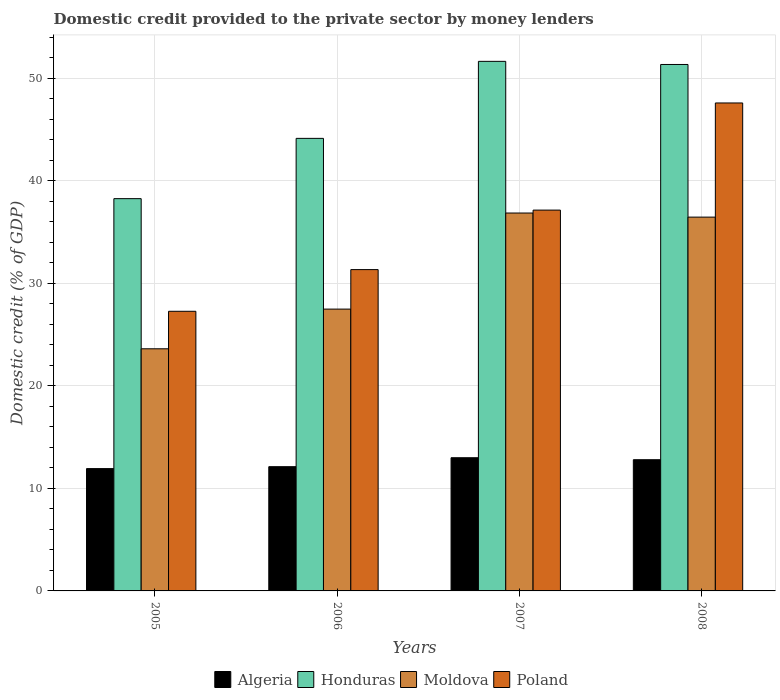How many bars are there on the 2nd tick from the left?
Provide a short and direct response. 4. How many bars are there on the 4th tick from the right?
Give a very brief answer. 4. What is the label of the 1st group of bars from the left?
Give a very brief answer. 2005. What is the domestic credit provided to the private sector by money lenders in Algeria in 2008?
Your answer should be compact. 12.8. Across all years, what is the maximum domestic credit provided to the private sector by money lenders in Poland?
Provide a short and direct response. 47.59. Across all years, what is the minimum domestic credit provided to the private sector by money lenders in Poland?
Provide a short and direct response. 27.27. In which year was the domestic credit provided to the private sector by money lenders in Moldova maximum?
Your response must be concise. 2007. In which year was the domestic credit provided to the private sector by money lenders in Algeria minimum?
Give a very brief answer. 2005. What is the total domestic credit provided to the private sector by money lenders in Honduras in the graph?
Provide a short and direct response. 185.38. What is the difference between the domestic credit provided to the private sector by money lenders in Algeria in 2005 and that in 2006?
Offer a very short reply. -0.19. What is the difference between the domestic credit provided to the private sector by money lenders in Algeria in 2007 and the domestic credit provided to the private sector by money lenders in Poland in 2005?
Provide a succinct answer. -14.28. What is the average domestic credit provided to the private sector by money lenders in Poland per year?
Your answer should be very brief. 35.83. In the year 2007, what is the difference between the domestic credit provided to the private sector by money lenders in Poland and domestic credit provided to the private sector by money lenders in Moldova?
Make the answer very short. 0.28. In how many years, is the domestic credit provided to the private sector by money lenders in Poland greater than 52 %?
Offer a very short reply. 0. What is the ratio of the domestic credit provided to the private sector by money lenders in Moldova in 2005 to that in 2006?
Keep it short and to the point. 0.86. Is the domestic credit provided to the private sector by money lenders in Honduras in 2005 less than that in 2006?
Make the answer very short. Yes. What is the difference between the highest and the second highest domestic credit provided to the private sector by money lenders in Poland?
Give a very brief answer. 10.45. What is the difference between the highest and the lowest domestic credit provided to the private sector by money lenders in Honduras?
Your response must be concise. 13.39. Is it the case that in every year, the sum of the domestic credit provided to the private sector by money lenders in Poland and domestic credit provided to the private sector by money lenders in Moldova is greater than the sum of domestic credit provided to the private sector by money lenders in Honduras and domestic credit provided to the private sector by money lenders in Algeria?
Your answer should be very brief. No. What does the 2nd bar from the left in 2008 represents?
Your answer should be compact. Honduras. What does the 4th bar from the right in 2008 represents?
Keep it short and to the point. Algeria. Is it the case that in every year, the sum of the domestic credit provided to the private sector by money lenders in Algeria and domestic credit provided to the private sector by money lenders in Moldova is greater than the domestic credit provided to the private sector by money lenders in Poland?
Offer a very short reply. Yes. How many bars are there?
Keep it short and to the point. 16. Are all the bars in the graph horizontal?
Provide a short and direct response. No. How many years are there in the graph?
Offer a terse response. 4. Does the graph contain grids?
Offer a very short reply. Yes. Where does the legend appear in the graph?
Your response must be concise. Bottom center. How are the legend labels stacked?
Your response must be concise. Horizontal. What is the title of the graph?
Ensure brevity in your answer.  Domestic credit provided to the private sector by money lenders. Does "Bosnia and Herzegovina" appear as one of the legend labels in the graph?
Provide a succinct answer. No. What is the label or title of the Y-axis?
Provide a short and direct response. Domestic credit (% of GDP). What is the Domestic credit (% of GDP) of Algeria in 2005?
Offer a very short reply. 11.93. What is the Domestic credit (% of GDP) in Honduras in 2005?
Give a very brief answer. 38.26. What is the Domestic credit (% of GDP) in Moldova in 2005?
Your answer should be compact. 23.61. What is the Domestic credit (% of GDP) in Poland in 2005?
Provide a succinct answer. 27.27. What is the Domestic credit (% of GDP) in Algeria in 2006?
Keep it short and to the point. 12.12. What is the Domestic credit (% of GDP) of Honduras in 2006?
Your answer should be very brief. 44.14. What is the Domestic credit (% of GDP) of Moldova in 2006?
Your response must be concise. 27.48. What is the Domestic credit (% of GDP) in Poland in 2006?
Offer a terse response. 31.34. What is the Domestic credit (% of GDP) in Algeria in 2007?
Provide a short and direct response. 12.99. What is the Domestic credit (% of GDP) in Honduras in 2007?
Offer a very short reply. 51.65. What is the Domestic credit (% of GDP) in Moldova in 2007?
Keep it short and to the point. 36.86. What is the Domestic credit (% of GDP) in Poland in 2007?
Offer a very short reply. 37.14. What is the Domestic credit (% of GDP) in Algeria in 2008?
Your response must be concise. 12.8. What is the Domestic credit (% of GDP) in Honduras in 2008?
Offer a terse response. 51.34. What is the Domestic credit (% of GDP) in Moldova in 2008?
Your response must be concise. 36.46. What is the Domestic credit (% of GDP) in Poland in 2008?
Your answer should be compact. 47.59. Across all years, what is the maximum Domestic credit (% of GDP) in Algeria?
Ensure brevity in your answer.  12.99. Across all years, what is the maximum Domestic credit (% of GDP) of Honduras?
Make the answer very short. 51.65. Across all years, what is the maximum Domestic credit (% of GDP) in Moldova?
Provide a succinct answer. 36.86. Across all years, what is the maximum Domestic credit (% of GDP) of Poland?
Give a very brief answer. 47.59. Across all years, what is the minimum Domestic credit (% of GDP) in Algeria?
Provide a succinct answer. 11.93. Across all years, what is the minimum Domestic credit (% of GDP) of Honduras?
Keep it short and to the point. 38.26. Across all years, what is the minimum Domestic credit (% of GDP) in Moldova?
Make the answer very short. 23.61. Across all years, what is the minimum Domestic credit (% of GDP) of Poland?
Your answer should be compact. 27.27. What is the total Domestic credit (% of GDP) of Algeria in the graph?
Provide a succinct answer. 49.83. What is the total Domestic credit (% of GDP) of Honduras in the graph?
Offer a terse response. 185.38. What is the total Domestic credit (% of GDP) in Moldova in the graph?
Your answer should be very brief. 124.41. What is the total Domestic credit (% of GDP) in Poland in the graph?
Offer a very short reply. 143.34. What is the difference between the Domestic credit (% of GDP) in Algeria in 2005 and that in 2006?
Make the answer very short. -0.19. What is the difference between the Domestic credit (% of GDP) of Honduras in 2005 and that in 2006?
Offer a terse response. -5.88. What is the difference between the Domestic credit (% of GDP) in Moldova in 2005 and that in 2006?
Offer a very short reply. -3.87. What is the difference between the Domestic credit (% of GDP) of Poland in 2005 and that in 2006?
Your answer should be very brief. -4.07. What is the difference between the Domestic credit (% of GDP) of Algeria in 2005 and that in 2007?
Give a very brief answer. -1.06. What is the difference between the Domestic credit (% of GDP) of Honduras in 2005 and that in 2007?
Provide a succinct answer. -13.39. What is the difference between the Domestic credit (% of GDP) in Moldova in 2005 and that in 2007?
Your answer should be compact. -13.24. What is the difference between the Domestic credit (% of GDP) in Poland in 2005 and that in 2007?
Offer a very short reply. -9.87. What is the difference between the Domestic credit (% of GDP) of Algeria in 2005 and that in 2008?
Make the answer very short. -0.87. What is the difference between the Domestic credit (% of GDP) of Honduras in 2005 and that in 2008?
Offer a very short reply. -13.09. What is the difference between the Domestic credit (% of GDP) in Moldova in 2005 and that in 2008?
Ensure brevity in your answer.  -12.84. What is the difference between the Domestic credit (% of GDP) of Poland in 2005 and that in 2008?
Your response must be concise. -20.32. What is the difference between the Domestic credit (% of GDP) of Algeria in 2006 and that in 2007?
Ensure brevity in your answer.  -0.87. What is the difference between the Domestic credit (% of GDP) in Honduras in 2006 and that in 2007?
Keep it short and to the point. -7.51. What is the difference between the Domestic credit (% of GDP) in Moldova in 2006 and that in 2007?
Offer a terse response. -9.37. What is the difference between the Domestic credit (% of GDP) of Poland in 2006 and that in 2007?
Your answer should be compact. -5.8. What is the difference between the Domestic credit (% of GDP) in Algeria in 2006 and that in 2008?
Your answer should be compact. -0.68. What is the difference between the Domestic credit (% of GDP) of Honduras in 2006 and that in 2008?
Make the answer very short. -7.21. What is the difference between the Domestic credit (% of GDP) in Moldova in 2006 and that in 2008?
Offer a terse response. -8.97. What is the difference between the Domestic credit (% of GDP) of Poland in 2006 and that in 2008?
Ensure brevity in your answer.  -16.25. What is the difference between the Domestic credit (% of GDP) of Algeria in 2007 and that in 2008?
Ensure brevity in your answer.  0.19. What is the difference between the Domestic credit (% of GDP) in Honduras in 2007 and that in 2008?
Give a very brief answer. 0.3. What is the difference between the Domestic credit (% of GDP) in Moldova in 2007 and that in 2008?
Keep it short and to the point. 0.4. What is the difference between the Domestic credit (% of GDP) of Poland in 2007 and that in 2008?
Your response must be concise. -10.45. What is the difference between the Domestic credit (% of GDP) of Algeria in 2005 and the Domestic credit (% of GDP) of Honduras in 2006?
Your answer should be very brief. -32.21. What is the difference between the Domestic credit (% of GDP) of Algeria in 2005 and the Domestic credit (% of GDP) of Moldova in 2006?
Make the answer very short. -15.56. What is the difference between the Domestic credit (% of GDP) in Algeria in 2005 and the Domestic credit (% of GDP) in Poland in 2006?
Your answer should be very brief. -19.41. What is the difference between the Domestic credit (% of GDP) in Honduras in 2005 and the Domestic credit (% of GDP) in Moldova in 2006?
Keep it short and to the point. 10.77. What is the difference between the Domestic credit (% of GDP) of Honduras in 2005 and the Domestic credit (% of GDP) of Poland in 2006?
Provide a short and direct response. 6.92. What is the difference between the Domestic credit (% of GDP) of Moldova in 2005 and the Domestic credit (% of GDP) of Poland in 2006?
Give a very brief answer. -7.72. What is the difference between the Domestic credit (% of GDP) in Algeria in 2005 and the Domestic credit (% of GDP) in Honduras in 2007?
Provide a succinct answer. -39.72. What is the difference between the Domestic credit (% of GDP) in Algeria in 2005 and the Domestic credit (% of GDP) in Moldova in 2007?
Your answer should be very brief. -24.93. What is the difference between the Domestic credit (% of GDP) in Algeria in 2005 and the Domestic credit (% of GDP) in Poland in 2007?
Your answer should be compact. -25.21. What is the difference between the Domestic credit (% of GDP) in Honduras in 2005 and the Domestic credit (% of GDP) in Moldova in 2007?
Give a very brief answer. 1.4. What is the difference between the Domestic credit (% of GDP) in Honduras in 2005 and the Domestic credit (% of GDP) in Poland in 2007?
Your response must be concise. 1.12. What is the difference between the Domestic credit (% of GDP) of Moldova in 2005 and the Domestic credit (% of GDP) of Poland in 2007?
Your answer should be very brief. -13.53. What is the difference between the Domestic credit (% of GDP) in Algeria in 2005 and the Domestic credit (% of GDP) in Honduras in 2008?
Make the answer very short. -39.41. What is the difference between the Domestic credit (% of GDP) of Algeria in 2005 and the Domestic credit (% of GDP) of Moldova in 2008?
Make the answer very short. -24.53. What is the difference between the Domestic credit (% of GDP) of Algeria in 2005 and the Domestic credit (% of GDP) of Poland in 2008?
Your answer should be very brief. -35.66. What is the difference between the Domestic credit (% of GDP) in Honduras in 2005 and the Domestic credit (% of GDP) in Moldova in 2008?
Provide a succinct answer. 1.8. What is the difference between the Domestic credit (% of GDP) of Honduras in 2005 and the Domestic credit (% of GDP) of Poland in 2008?
Ensure brevity in your answer.  -9.33. What is the difference between the Domestic credit (% of GDP) in Moldova in 2005 and the Domestic credit (% of GDP) in Poland in 2008?
Ensure brevity in your answer.  -23.97. What is the difference between the Domestic credit (% of GDP) in Algeria in 2006 and the Domestic credit (% of GDP) in Honduras in 2007?
Give a very brief answer. -39.53. What is the difference between the Domestic credit (% of GDP) in Algeria in 2006 and the Domestic credit (% of GDP) in Moldova in 2007?
Offer a very short reply. -24.74. What is the difference between the Domestic credit (% of GDP) of Algeria in 2006 and the Domestic credit (% of GDP) of Poland in 2007?
Ensure brevity in your answer.  -25.02. What is the difference between the Domestic credit (% of GDP) of Honduras in 2006 and the Domestic credit (% of GDP) of Moldova in 2007?
Provide a short and direct response. 7.28. What is the difference between the Domestic credit (% of GDP) of Honduras in 2006 and the Domestic credit (% of GDP) of Poland in 2007?
Keep it short and to the point. 7. What is the difference between the Domestic credit (% of GDP) in Moldova in 2006 and the Domestic credit (% of GDP) in Poland in 2007?
Ensure brevity in your answer.  -9.66. What is the difference between the Domestic credit (% of GDP) of Algeria in 2006 and the Domestic credit (% of GDP) of Honduras in 2008?
Offer a very short reply. -39.23. What is the difference between the Domestic credit (% of GDP) in Algeria in 2006 and the Domestic credit (% of GDP) in Moldova in 2008?
Make the answer very short. -24.34. What is the difference between the Domestic credit (% of GDP) in Algeria in 2006 and the Domestic credit (% of GDP) in Poland in 2008?
Provide a short and direct response. -35.47. What is the difference between the Domestic credit (% of GDP) in Honduras in 2006 and the Domestic credit (% of GDP) in Moldova in 2008?
Offer a very short reply. 7.68. What is the difference between the Domestic credit (% of GDP) in Honduras in 2006 and the Domestic credit (% of GDP) in Poland in 2008?
Make the answer very short. -3.45. What is the difference between the Domestic credit (% of GDP) of Moldova in 2006 and the Domestic credit (% of GDP) of Poland in 2008?
Give a very brief answer. -20.1. What is the difference between the Domestic credit (% of GDP) of Algeria in 2007 and the Domestic credit (% of GDP) of Honduras in 2008?
Give a very brief answer. -38.35. What is the difference between the Domestic credit (% of GDP) of Algeria in 2007 and the Domestic credit (% of GDP) of Moldova in 2008?
Your response must be concise. -23.47. What is the difference between the Domestic credit (% of GDP) of Algeria in 2007 and the Domestic credit (% of GDP) of Poland in 2008?
Your answer should be very brief. -34.6. What is the difference between the Domestic credit (% of GDP) in Honduras in 2007 and the Domestic credit (% of GDP) in Moldova in 2008?
Your response must be concise. 15.19. What is the difference between the Domestic credit (% of GDP) of Honduras in 2007 and the Domestic credit (% of GDP) of Poland in 2008?
Ensure brevity in your answer.  4.06. What is the difference between the Domestic credit (% of GDP) in Moldova in 2007 and the Domestic credit (% of GDP) in Poland in 2008?
Provide a short and direct response. -10.73. What is the average Domestic credit (% of GDP) of Algeria per year?
Keep it short and to the point. 12.46. What is the average Domestic credit (% of GDP) in Honduras per year?
Offer a terse response. 46.35. What is the average Domestic credit (% of GDP) in Moldova per year?
Provide a succinct answer. 31.1. What is the average Domestic credit (% of GDP) in Poland per year?
Your answer should be very brief. 35.83. In the year 2005, what is the difference between the Domestic credit (% of GDP) in Algeria and Domestic credit (% of GDP) in Honduras?
Make the answer very short. -26.33. In the year 2005, what is the difference between the Domestic credit (% of GDP) in Algeria and Domestic credit (% of GDP) in Moldova?
Your answer should be very brief. -11.68. In the year 2005, what is the difference between the Domestic credit (% of GDP) in Algeria and Domestic credit (% of GDP) in Poland?
Offer a terse response. -15.34. In the year 2005, what is the difference between the Domestic credit (% of GDP) in Honduras and Domestic credit (% of GDP) in Moldova?
Ensure brevity in your answer.  14.64. In the year 2005, what is the difference between the Domestic credit (% of GDP) of Honduras and Domestic credit (% of GDP) of Poland?
Your answer should be compact. 10.99. In the year 2005, what is the difference between the Domestic credit (% of GDP) in Moldova and Domestic credit (% of GDP) in Poland?
Your answer should be compact. -3.66. In the year 2006, what is the difference between the Domestic credit (% of GDP) of Algeria and Domestic credit (% of GDP) of Honduras?
Your answer should be compact. -32.02. In the year 2006, what is the difference between the Domestic credit (% of GDP) of Algeria and Domestic credit (% of GDP) of Moldova?
Your answer should be very brief. -15.37. In the year 2006, what is the difference between the Domestic credit (% of GDP) in Algeria and Domestic credit (% of GDP) in Poland?
Give a very brief answer. -19.22. In the year 2006, what is the difference between the Domestic credit (% of GDP) of Honduras and Domestic credit (% of GDP) of Moldova?
Offer a terse response. 16.65. In the year 2006, what is the difference between the Domestic credit (% of GDP) of Honduras and Domestic credit (% of GDP) of Poland?
Ensure brevity in your answer.  12.8. In the year 2006, what is the difference between the Domestic credit (% of GDP) in Moldova and Domestic credit (% of GDP) in Poland?
Provide a succinct answer. -3.85. In the year 2007, what is the difference between the Domestic credit (% of GDP) in Algeria and Domestic credit (% of GDP) in Honduras?
Your answer should be very brief. -38.66. In the year 2007, what is the difference between the Domestic credit (% of GDP) in Algeria and Domestic credit (% of GDP) in Moldova?
Keep it short and to the point. -23.87. In the year 2007, what is the difference between the Domestic credit (% of GDP) of Algeria and Domestic credit (% of GDP) of Poland?
Offer a terse response. -24.15. In the year 2007, what is the difference between the Domestic credit (% of GDP) in Honduras and Domestic credit (% of GDP) in Moldova?
Your answer should be very brief. 14.79. In the year 2007, what is the difference between the Domestic credit (% of GDP) in Honduras and Domestic credit (% of GDP) in Poland?
Keep it short and to the point. 14.51. In the year 2007, what is the difference between the Domestic credit (% of GDP) of Moldova and Domestic credit (% of GDP) of Poland?
Your answer should be very brief. -0.28. In the year 2008, what is the difference between the Domestic credit (% of GDP) in Algeria and Domestic credit (% of GDP) in Honduras?
Offer a terse response. -38.55. In the year 2008, what is the difference between the Domestic credit (% of GDP) in Algeria and Domestic credit (% of GDP) in Moldova?
Provide a succinct answer. -23.66. In the year 2008, what is the difference between the Domestic credit (% of GDP) of Algeria and Domestic credit (% of GDP) of Poland?
Provide a short and direct response. -34.79. In the year 2008, what is the difference between the Domestic credit (% of GDP) in Honduras and Domestic credit (% of GDP) in Moldova?
Your answer should be compact. 14.89. In the year 2008, what is the difference between the Domestic credit (% of GDP) of Honduras and Domestic credit (% of GDP) of Poland?
Provide a short and direct response. 3.75. In the year 2008, what is the difference between the Domestic credit (% of GDP) in Moldova and Domestic credit (% of GDP) in Poland?
Your answer should be compact. -11.13. What is the ratio of the Domestic credit (% of GDP) in Algeria in 2005 to that in 2006?
Offer a very short reply. 0.98. What is the ratio of the Domestic credit (% of GDP) in Honduras in 2005 to that in 2006?
Ensure brevity in your answer.  0.87. What is the ratio of the Domestic credit (% of GDP) of Moldova in 2005 to that in 2006?
Provide a short and direct response. 0.86. What is the ratio of the Domestic credit (% of GDP) in Poland in 2005 to that in 2006?
Your response must be concise. 0.87. What is the ratio of the Domestic credit (% of GDP) of Algeria in 2005 to that in 2007?
Offer a very short reply. 0.92. What is the ratio of the Domestic credit (% of GDP) of Honduras in 2005 to that in 2007?
Offer a terse response. 0.74. What is the ratio of the Domestic credit (% of GDP) of Moldova in 2005 to that in 2007?
Make the answer very short. 0.64. What is the ratio of the Domestic credit (% of GDP) in Poland in 2005 to that in 2007?
Keep it short and to the point. 0.73. What is the ratio of the Domestic credit (% of GDP) in Algeria in 2005 to that in 2008?
Provide a short and direct response. 0.93. What is the ratio of the Domestic credit (% of GDP) in Honduras in 2005 to that in 2008?
Ensure brevity in your answer.  0.75. What is the ratio of the Domestic credit (% of GDP) in Moldova in 2005 to that in 2008?
Offer a very short reply. 0.65. What is the ratio of the Domestic credit (% of GDP) in Poland in 2005 to that in 2008?
Provide a short and direct response. 0.57. What is the ratio of the Domestic credit (% of GDP) of Algeria in 2006 to that in 2007?
Provide a short and direct response. 0.93. What is the ratio of the Domestic credit (% of GDP) of Honduras in 2006 to that in 2007?
Your answer should be compact. 0.85. What is the ratio of the Domestic credit (% of GDP) of Moldova in 2006 to that in 2007?
Make the answer very short. 0.75. What is the ratio of the Domestic credit (% of GDP) of Poland in 2006 to that in 2007?
Your response must be concise. 0.84. What is the ratio of the Domestic credit (% of GDP) of Algeria in 2006 to that in 2008?
Provide a short and direct response. 0.95. What is the ratio of the Domestic credit (% of GDP) of Honduras in 2006 to that in 2008?
Provide a short and direct response. 0.86. What is the ratio of the Domestic credit (% of GDP) in Moldova in 2006 to that in 2008?
Your answer should be very brief. 0.75. What is the ratio of the Domestic credit (% of GDP) in Poland in 2006 to that in 2008?
Offer a terse response. 0.66. What is the ratio of the Domestic credit (% of GDP) of Algeria in 2007 to that in 2008?
Give a very brief answer. 1.02. What is the ratio of the Domestic credit (% of GDP) of Honduras in 2007 to that in 2008?
Your answer should be very brief. 1.01. What is the ratio of the Domestic credit (% of GDP) in Moldova in 2007 to that in 2008?
Your answer should be compact. 1.01. What is the ratio of the Domestic credit (% of GDP) of Poland in 2007 to that in 2008?
Keep it short and to the point. 0.78. What is the difference between the highest and the second highest Domestic credit (% of GDP) of Algeria?
Make the answer very short. 0.19. What is the difference between the highest and the second highest Domestic credit (% of GDP) of Honduras?
Keep it short and to the point. 0.3. What is the difference between the highest and the second highest Domestic credit (% of GDP) of Moldova?
Make the answer very short. 0.4. What is the difference between the highest and the second highest Domestic credit (% of GDP) in Poland?
Your answer should be very brief. 10.45. What is the difference between the highest and the lowest Domestic credit (% of GDP) in Algeria?
Provide a short and direct response. 1.06. What is the difference between the highest and the lowest Domestic credit (% of GDP) of Honduras?
Provide a short and direct response. 13.39. What is the difference between the highest and the lowest Domestic credit (% of GDP) of Moldova?
Give a very brief answer. 13.24. What is the difference between the highest and the lowest Domestic credit (% of GDP) of Poland?
Make the answer very short. 20.32. 